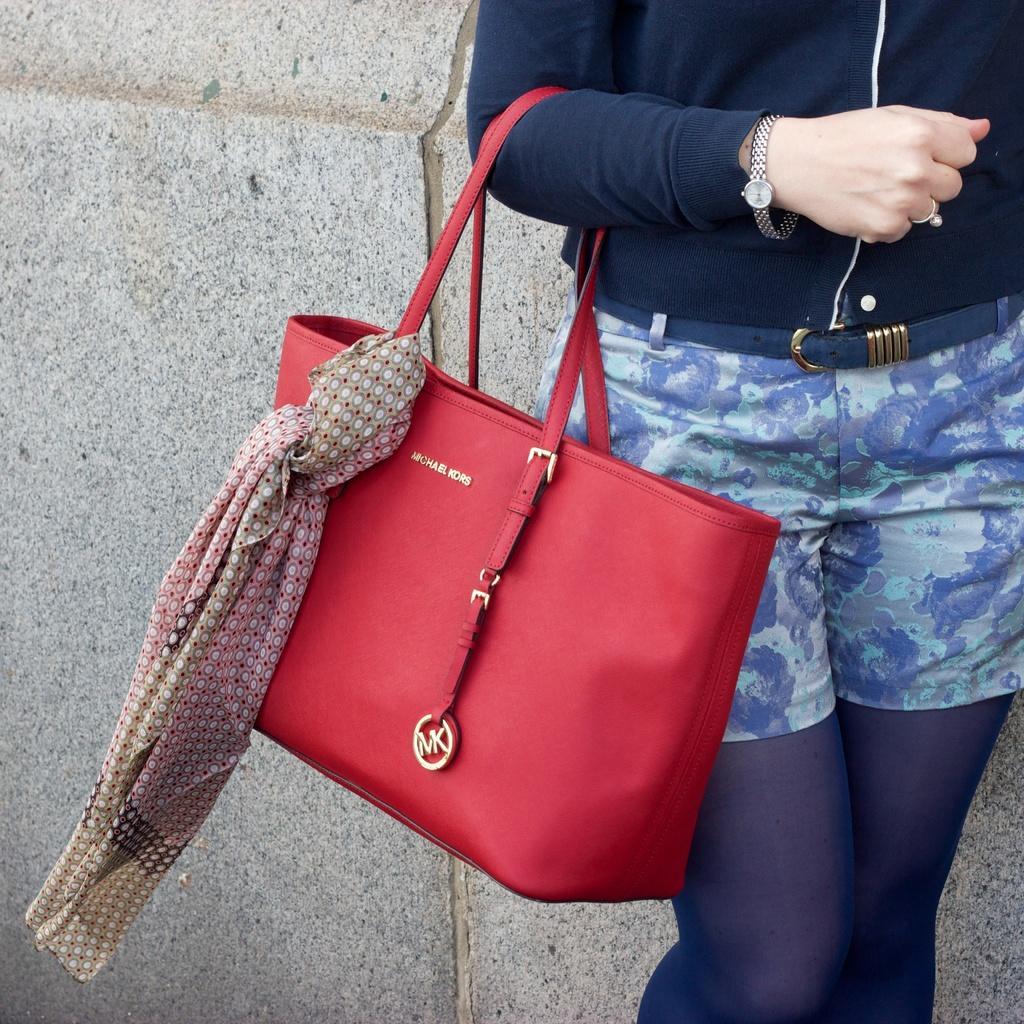Please provide a concise description of this image. A woman is carrying handbag on her hand. A cloth is tied to the hand bag and there is a wall behind her. 